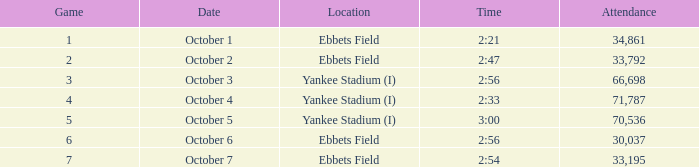Date of October 1 has what average game? 1.0. 